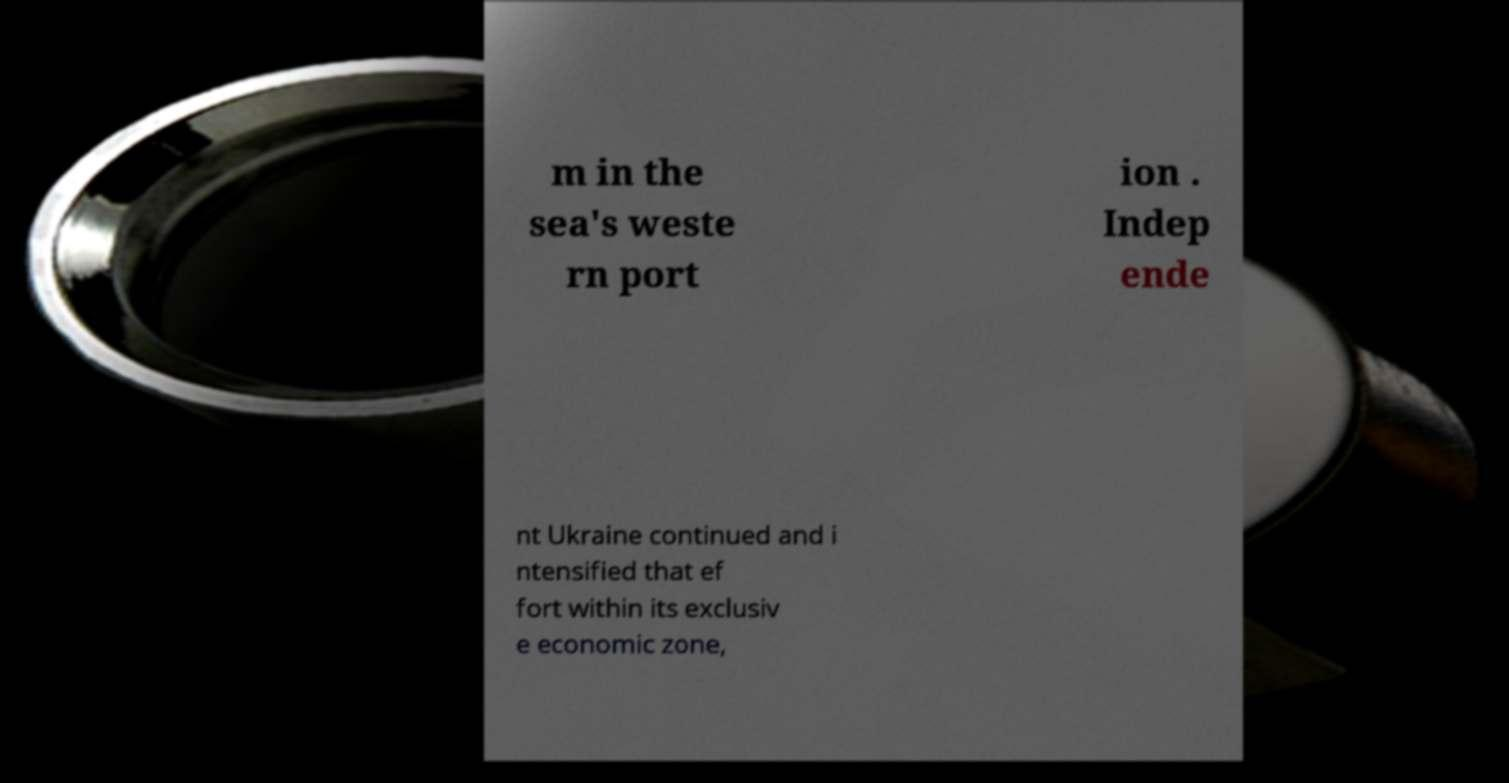Can you accurately transcribe the text from the provided image for me? m in the sea's weste rn port ion . Indep ende nt Ukraine continued and i ntensified that ef fort within its exclusiv e economic zone, 